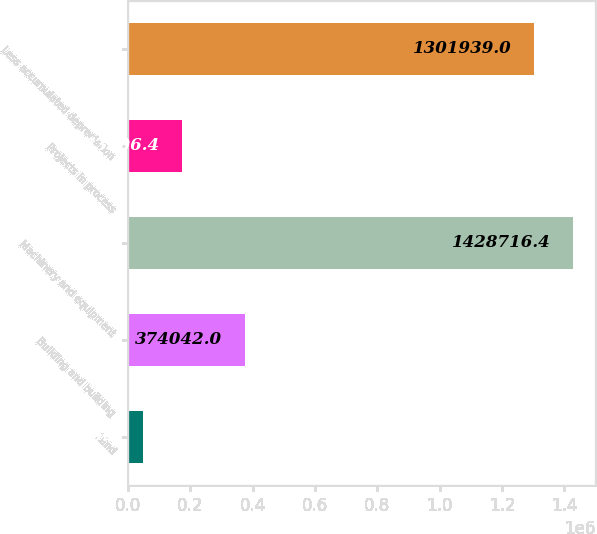Convert chart. <chart><loc_0><loc_0><loc_500><loc_500><bar_chart><fcel>Land<fcel>Building and building<fcel>Machinery and equipment<fcel>Projects in process<fcel>Less accumulated depreciation<nl><fcel>46529<fcel>374042<fcel>1.42872e+06<fcel>173306<fcel>1.30194e+06<nl></chart> 